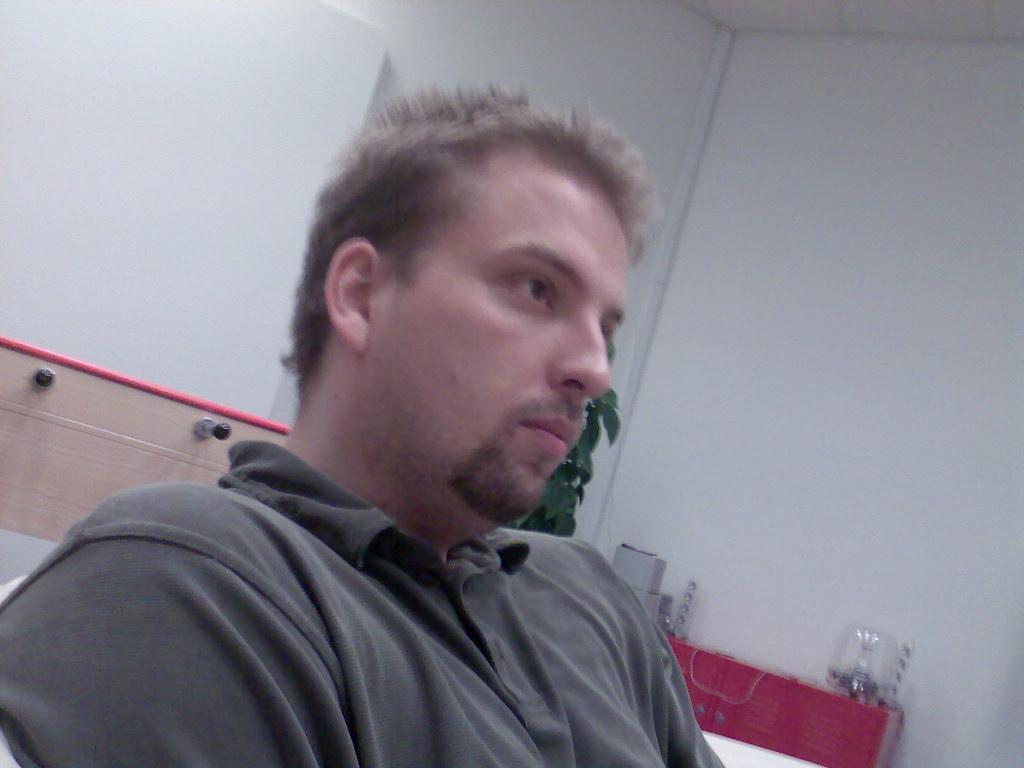Can you describe this image briefly? In this image we can see a person. There are few objects at the right side of the person. There is a wooden object behind a person. 